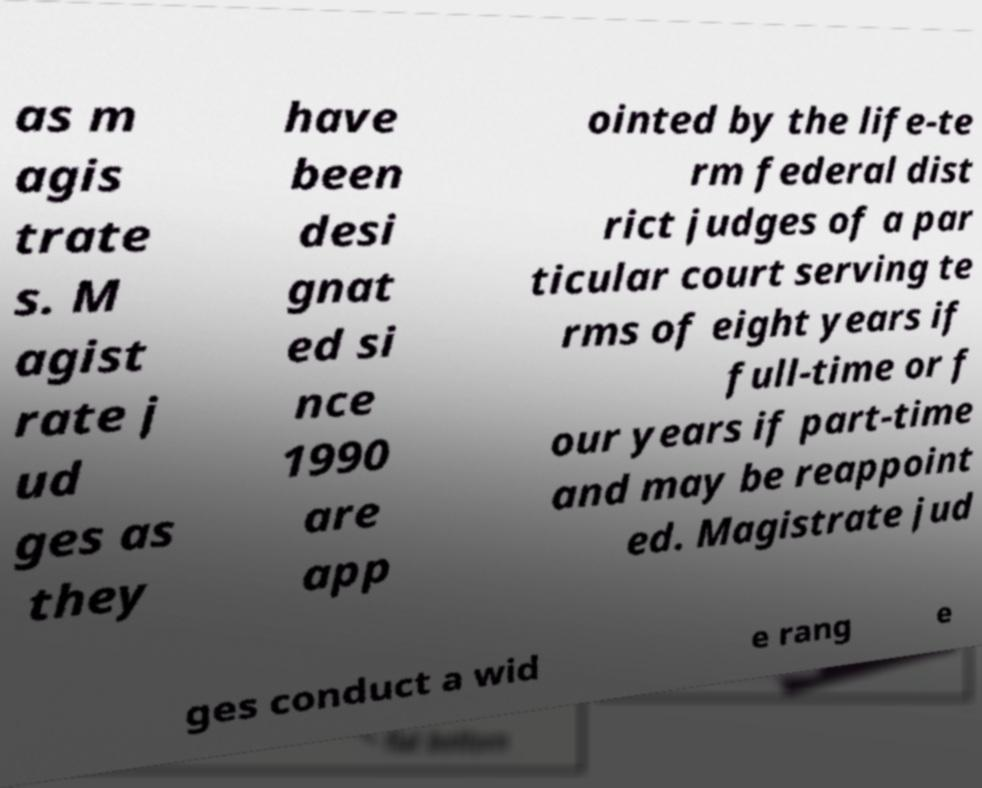There's text embedded in this image that I need extracted. Can you transcribe it verbatim? as m agis trate s. M agist rate j ud ges as they have been desi gnat ed si nce 1990 are app ointed by the life-te rm federal dist rict judges of a par ticular court serving te rms of eight years if full-time or f our years if part-time and may be reappoint ed. Magistrate jud ges conduct a wid e rang e 